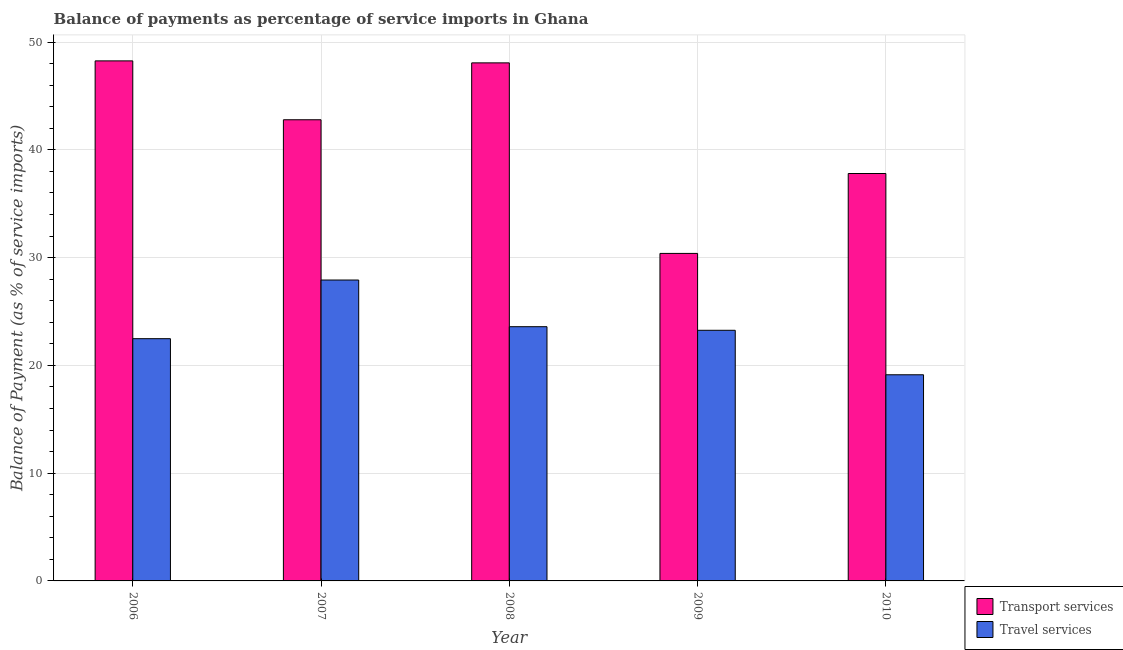How many different coloured bars are there?
Make the answer very short. 2. How many groups of bars are there?
Make the answer very short. 5. Are the number of bars on each tick of the X-axis equal?
Your answer should be compact. Yes. How many bars are there on the 1st tick from the left?
Ensure brevity in your answer.  2. What is the label of the 3rd group of bars from the left?
Keep it short and to the point. 2008. In how many cases, is the number of bars for a given year not equal to the number of legend labels?
Provide a succinct answer. 0. What is the balance of payments of transport services in 2010?
Keep it short and to the point. 37.8. Across all years, what is the maximum balance of payments of transport services?
Give a very brief answer. 48.25. Across all years, what is the minimum balance of payments of transport services?
Provide a succinct answer. 30.39. In which year was the balance of payments of travel services maximum?
Give a very brief answer. 2007. What is the total balance of payments of travel services in the graph?
Your answer should be very brief. 116.37. What is the difference between the balance of payments of transport services in 2006 and that in 2010?
Offer a very short reply. 10.45. What is the difference between the balance of payments of transport services in 2009 and the balance of payments of travel services in 2007?
Give a very brief answer. -12.4. What is the average balance of payments of transport services per year?
Your answer should be compact. 41.46. In the year 2010, what is the difference between the balance of payments of transport services and balance of payments of travel services?
Provide a succinct answer. 0. In how many years, is the balance of payments of travel services greater than 4 %?
Offer a terse response. 5. What is the ratio of the balance of payments of travel services in 2008 to that in 2010?
Your response must be concise. 1.23. Is the balance of payments of transport services in 2006 less than that in 2010?
Make the answer very short. No. What is the difference between the highest and the second highest balance of payments of transport services?
Your answer should be very brief. 0.18. What is the difference between the highest and the lowest balance of payments of travel services?
Your response must be concise. 8.79. Is the sum of the balance of payments of transport services in 2006 and 2009 greater than the maximum balance of payments of travel services across all years?
Your response must be concise. Yes. What does the 1st bar from the left in 2007 represents?
Your answer should be very brief. Transport services. What does the 1st bar from the right in 2009 represents?
Make the answer very short. Travel services. How many bars are there?
Your response must be concise. 10. Are all the bars in the graph horizontal?
Your answer should be compact. No. Are the values on the major ticks of Y-axis written in scientific E-notation?
Offer a very short reply. No. Does the graph contain any zero values?
Provide a short and direct response. No. Does the graph contain grids?
Make the answer very short. Yes. What is the title of the graph?
Offer a very short reply. Balance of payments as percentage of service imports in Ghana. What is the label or title of the X-axis?
Your answer should be very brief. Year. What is the label or title of the Y-axis?
Keep it short and to the point. Balance of Payment (as % of service imports). What is the Balance of Payment (as % of service imports) in Transport services in 2006?
Offer a terse response. 48.25. What is the Balance of Payment (as % of service imports) of Travel services in 2006?
Keep it short and to the point. 22.48. What is the Balance of Payment (as % of service imports) of Transport services in 2007?
Make the answer very short. 42.79. What is the Balance of Payment (as % of service imports) of Travel services in 2007?
Provide a short and direct response. 27.92. What is the Balance of Payment (as % of service imports) of Transport services in 2008?
Keep it short and to the point. 48.07. What is the Balance of Payment (as % of service imports) of Travel services in 2008?
Your answer should be compact. 23.59. What is the Balance of Payment (as % of service imports) of Transport services in 2009?
Provide a succinct answer. 30.39. What is the Balance of Payment (as % of service imports) of Travel services in 2009?
Keep it short and to the point. 23.26. What is the Balance of Payment (as % of service imports) of Transport services in 2010?
Your response must be concise. 37.8. What is the Balance of Payment (as % of service imports) of Travel services in 2010?
Keep it short and to the point. 19.13. Across all years, what is the maximum Balance of Payment (as % of service imports) in Transport services?
Your response must be concise. 48.25. Across all years, what is the maximum Balance of Payment (as % of service imports) in Travel services?
Your answer should be compact. 27.92. Across all years, what is the minimum Balance of Payment (as % of service imports) in Transport services?
Provide a succinct answer. 30.39. Across all years, what is the minimum Balance of Payment (as % of service imports) of Travel services?
Provide a short and direct response. 19.13. What is the total Balance of Payment (as % of service imports) of Transport services in the graph?
Offer a very short reply. 207.3. What is the total Balance of Payment (as % of service imports) in Travel services in the graph?
Provide a short and direct response. 116.37. What is the difference between the Balance of Payment (as % of service imports) in Transport services in 2006 and that in 2007?
Ensure brevity in your answer.  5.46. What is the difference between the Balance of Payment (as % of service imports) of Travel services in 2006 and that in 2007?
Keep it short and to the point. -5.44. What is the difference between the Balance of Payment (as % of service imports) of Transport services in 2006 and that in 2008?
Offer a very short reply. 0.18. What is the difference between the Balance of Payment (as % of service imports) in Travel services in 2006 and that in 2008?
Keep it short and to the point. -1.11. What is the difference between the Balance of Payment (as % of service imports) in Transport services in 2006 and that in 2009?
Provide a short and direct response. 17.86. What is the difference between the Balance of Payment (as % of service imports) of Travel services in 2006 and that in 2009?
Your answer should be compact. -0.78. What is the difference between the Balance of Payment (as % of service imports) in Transport services in 2006 and that in 2010?
Your response must be concise. 10.45. What is the difference between the Balance of Payment (as % of service imports) in Travel services in 2006 and that in 2010?
Offer a very short reply. 3.35. What is the difference between the Balance of Payment (as % of service imports) in Transport services in 2007 and that in 2008?
Your answer should be very brief. -5.28. What is the difference between the Balance of Payment (as % of service imports) in Travel services in 2007 and that in 2008?
Offer a very short reply. 4.33. What is the difference between the Balance of Payment (as % of service imports) in Transport services in 2007 and that in 2009?
Offer a very short reply. 12.4. What is the difference between the Balance of Payment (as % of service imports) in Travel services in 2007 and that in 2009?
Ensure brevity in your answer.  4.66. What is the difference between the Balance of Payment (as % of service imports) of Transport services in 2007 and that in 2010?
Provide a short and direct response. 4.99. What is the difference between the Balance of Payment (as % of service imports) of Travel services in 2007 and that in 2010?
Keep it short and to the point. 8.79. What is the difference between the Balance of Payment (as % of service imports) of Transport services in 2008 and that in 2009?
Make the answer very short. 17.68. What is the difference between the Balance of Payment (as % of service imports) of Travel services in 2008 and that in 2009?
Provide a succinct answer. 0.33. What is the difference between the Balance of Payment (as % of service imports) in Transport services in 2008 and that in 2010?
Offer a very short reply. 10.27. What is the difference between the Balance of Payment (as % of service imports) in Travel services in 2008 and that in 2010?
Your answer should be compact. 4.46. What is the difference between the Balance of Payment (as % of service imports) of Transport services in 2009 and that in 2010?
Your answer should be compact. -7.41. What is the difference between the Balance of Payment (as % of service imports) in Travel services in 2009 and that in 2010?
Provide a succinct answer. 4.13. What is the difference between the Balance of Payment (as % of service imports) of Transport services in 2006 and the Balance of Payment (as % of service imports) of Travel services in 2007?
Provide a short and direct response. 20.33. What is the difference between the Balance of Payment (as % of service imports) of Transport services in 2006 and the Balance of Payment (as % of service imports) of Travel services in 2008?
Your answer should be compact. 24.66. What is the difference between the Balance of Payment (as % of service imports) of Transport services in 2006 and the Balance of Payment (as % of service imports) of Travel services in 2009?
Provide a short and direct response. 25. What is the difference between the Balance of Payment (as % of service imports) of Transport services in 2006 and the Balance of Payment (as % of service imports) of Travel services in 2010?
Give a very brief answer. 29.13. What is the difference between the Balance of Payment (as % of service imports) in Transport services in 2007 and the Balance of Payment (as % of service imports) in Travel services in 2008?
Ensure brevity in your answer.  19.2. What is the difference between the Balance of Payment (as % of service imports) of Transport services in 2007 and the Balance of Payment (as % of service imports) of Travel services in 2009?
Offer a very short reply. 19.53. What is the difference between the Balance of Payment (as % of service imports) of Transport services in 2007 and the Balance of Payment (as % of service imports) of Travel services in 2010?
Your answer should be compact. 23.66. What is the difference between the Balance of Payment (as % of service imports) in Transport services in 2008 and the Balance of Payment (as % of service imports) in Travel services in 2009?
Your answer should be very brief. 24.81. What is the difference between the Balance of Payment (as % of service imports) in Transport services in 2008 and the Balance of Payment (as % of service imports) in Travel services in 2010?
Provide a short and direct response. 28.94. What is the difference between the Balance of Payment (as % of service imports) of Transport services in 2009 and the Balance of Payment (as % of service imports) of Travel services in 2010?
Ensure brevity in your answer.  11.26. What is the average Balance of Payment (as % of service imports) in Transport services per year?
Offer a very short reply. 41.46. What is the average Balance of Payment (as % of service imports) of Travel services per year?
Give a very brief answer. 23.27. In the year 2006, what is the difference between the Balance of Payment (as % of service imports) in Transport services and Balance of Payment (as % of service imports) in Travel services?
Provide a short and direct response. 25.78. In the year 2007, what is the difference between the Balance of Payment (as % of service imports) in Transport services and Balance of Payment (as % of service imports) in Travel services?
Provide a short and direct response. 14.87. In the year 2008, what is the difference between the Balance of Payment (as % of service imports) of Transport services and Balance of Payment (as % of service imports) of Travel services?
Your answer should be very brief. 24.48. In the year 2009, what is the difference between the Balance of Payment (as % of service imports) of Transport services and Balance of Payment (as % of service imports) of Travel services?
Your answer should be very brief. 7.13. In the year 2010, what is the difference between the Balance of Payment (as % of service imports) of Transport services and Balance of Payment (as % of service imports) of Travel services?
Your answer should be very brief. 18.68. What is the ratio of the Balance of Payment (as % of service imports) of Transport services in 2006 to that in 2007?
Your response must be concise. 1.13. What is the ratio of the Balance of Payment (as % of service imports) in Travel services in 2006 to that in 2007?
Ensure brevity in your answer.  0.81. What is the ratio of the Balance of Payment (as % of service imports) in Travel services in 2006 to that in 2008?
Keep it short and to the point. 0.95. What is the ratio of the Balance of Payment (as % of service imports) of Transport services in 2006 to that in 2009?
Provide a short and direct response. 1.59. What is the ratio of the Balance of Payment (as % of service imports) in Travel services in 2006 to that in 2009?
Make the answer very short. 0.97. What is the ratio of the Balance of Payment (as % of service imports) of Transport services in 2006 to that in 2010?
Provide a succinct answer. 1.28. What is the ratio of the Balance of Payment (as % of service imports) in Travel services in 2006 to that in 2010?
Offer a very short reply. 1.18. What is the ratio of the Balance of Payment (as % of service imports) in Transport services in 2007 to that in 2008?
Your response must be concise. 0.89. What is the ratio of the Balance of Payment (as % of service imports) of Travel services in 2007 to that in 2008?
Offer a terse response. 1.18. What is the ratio of the Balance of Payment (as % of service imports) of Transport services in 2007 to that in 2009?
Offer a very short reply. 1.41. What is the ratio of the Balance of Payment (as % of service imports) of Travel services in 2007 to that in 2009?
Your response must be concise. 1.2. What is the ratio of the Balance of Payment (as % of service imports) of Transport services in 2007 to that in 2010?
Offer a very short reply. 1.13. What is the ratio of the Balance of Payment (as % of service imports) of Travel services in 2007 to that in 2010?
Your answer should be compact. 1.46. What is the ratio of the Balance of Payment (as % of service imports) in Transport services in 2008 to that in 2009?
Provide a short and direct response. 1.58. What is the ratio of the Balance of Payment (as % of service imports) of Travel services in 2008 to that in 2009?
Keep it short and to the point. 1.01. What is the ratio of the Balance of Payment (as % of service imports) in Transport services in 2008 to that in 2010?
Your response must be concise. 1.27. What is the ratio of the Balance of Payment (as % of service imports) in Travel services in 2008 to that in 2010?
Your answer should be very brief. 1.23. What is the ratio of the Balance of Payment (as % of service imports) of Transport services in 2009 to that in 2010?
Provide a short and direct response. 0.8. What is the ratio of the Balance of Payment (as % of service imports) in Travel services in 2009 to that in 2010?
Offer a very short reply. 1.22. What is the difference between the highest and the second highest Balance of Payment (as % of service imports) of Transport services?
Provide a succinct answer. 0.18. What is the difference between the highest and the second highest Balance of Payment (as % of service imports) of Travel services?
Keep it short and to the point. 4.33. What is the difference between the highest and the lowest Balance of Payment (as % of service imports) in Transport services?
Your response must be concise. 17.86. What is the difference between the highest and the lowest Balance of Payment (as % of service imports) of Travel services?
Make the answer very short. 8.79. 